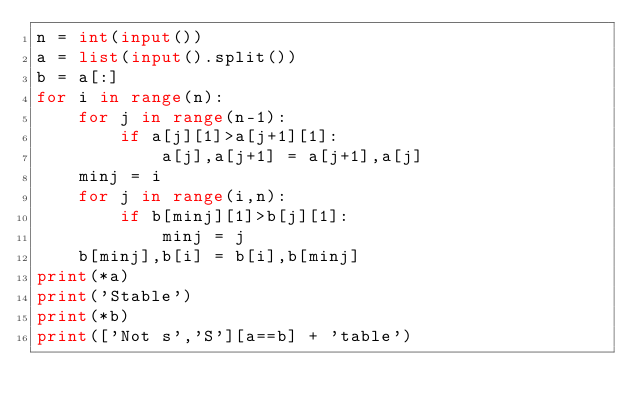<code> <loc_0><loc_0><loc_500><loc_500><_Python_>n = int(input())
a = list(input().split())
b = a[:]
for i in range(n):
    for j in range(n-1):
        if a[j][1]>a[j+1][1]:
            a[j],a[j+1] = a[j+1],a[j]
    minj = i
    for j in range(i,n):
        if b[minj][1]>b[j][1]:
            minj = j
    b[minj],b[i] = b[i],b[minj]        
print(*a)
print('Stable')
print(*b)
print(['Not s','S'][a==b] + 'table')



</code> 